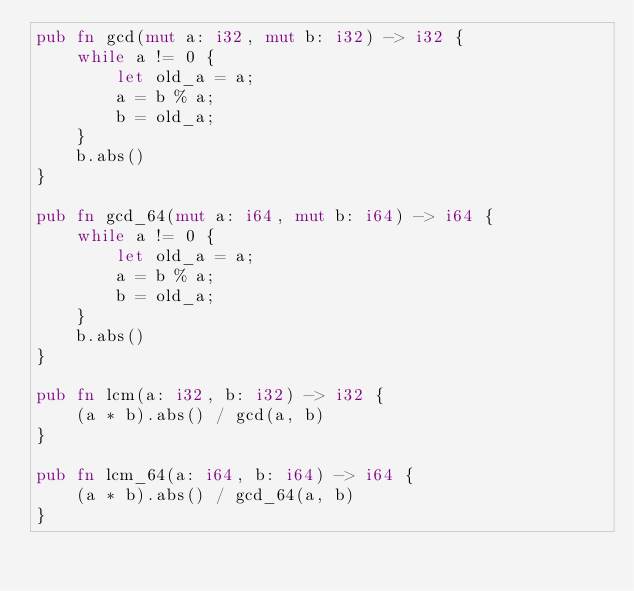<code> <loc_0><loc_0><loc_500><loc_500><_Rust_>pub fn gcd(mut a: i32, mut b: i32) -> i32 {
    while a != 0 {
        let old_a = a;
        a = b % a;
        b = old_a;
    }
    b.abs()
}

pub fn gcd_64(mut a: i64, mut b: i64) -> i64 {
    while a != 0 {
        let old_a = a;
        a = b % a;
        b = old_a;
    }
    b.abs()
}

pub fn lcm(a: i32, b: i32) -> i32 {
    (a * b).abs() / gcd(a, b)
}

pub fn lcm_64(a: i64, b: i64) -> i64 {
    (a * b).abs() / gcd_64(a, b)
}
</code> 